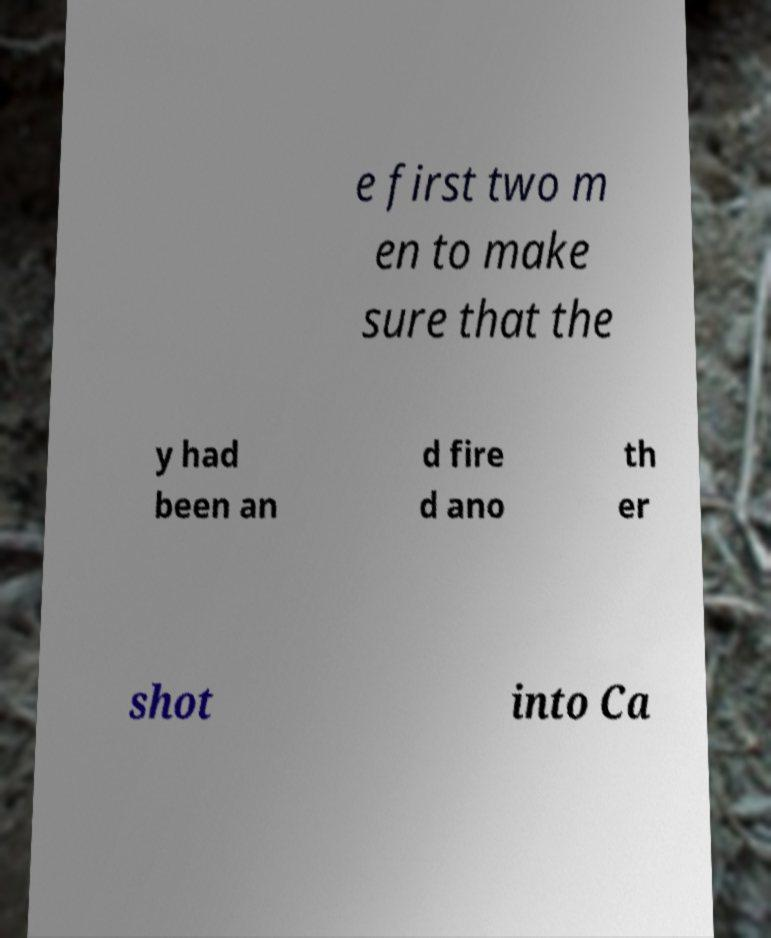There's text embedded in this image that I need extracted. Can you transcribe it verbatim? e first two m en to make sure that the y had been an d fire d ano th er shot into Ca 